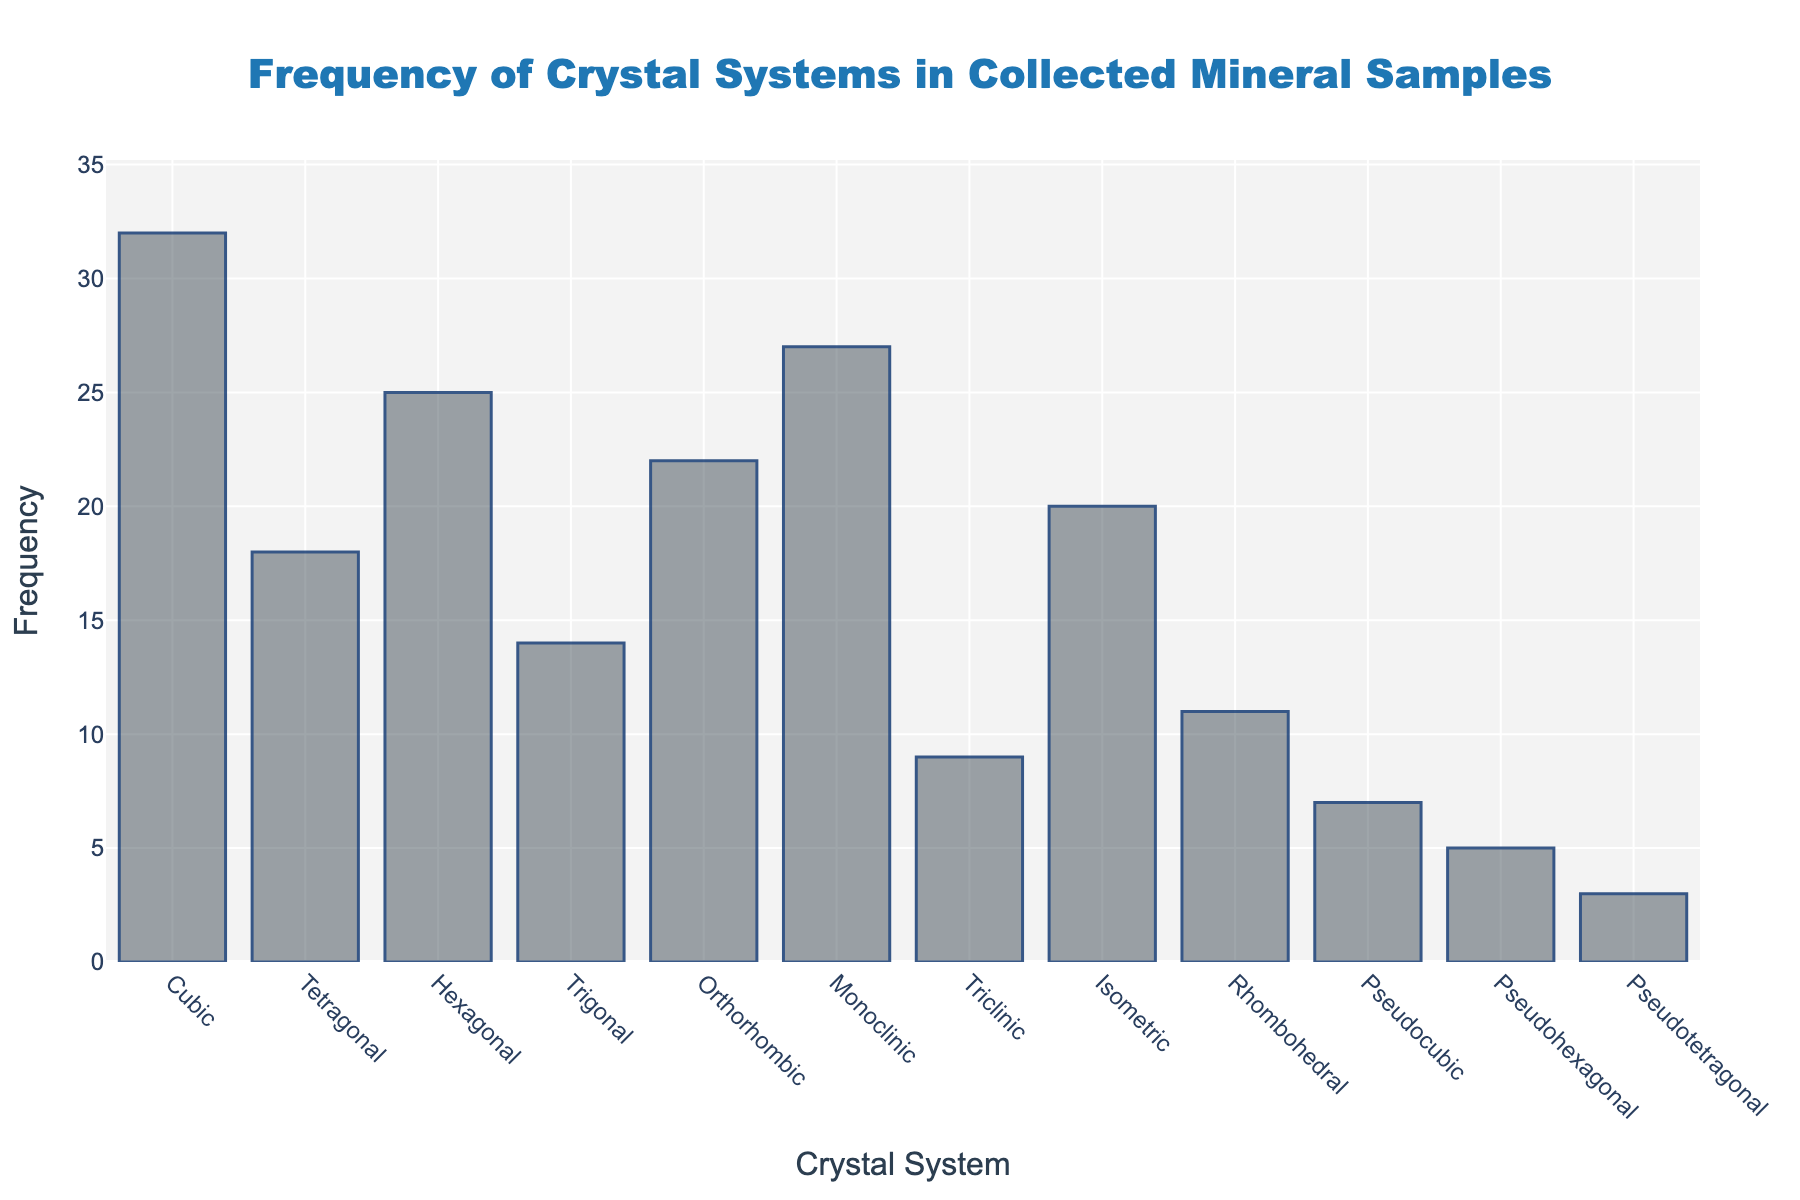What is the most frequently found crystal system in the collected mineral samples? Identify the bar with the highest value on the y-axis, which represents frequency. The highest bar corresponds to the cubic crystal system at a frequency of 32.
Answer: Cubic Which two crystal systems have the lowest frequencies? Identify the bars with the lowest heights on the y-axis. The pseudohexagonal and pseudotetragonal systems have the lowest frequencies at 5 and 3, respectively.
Answer: Pseudohexagonal and Pseudotetragonal What is the total frequency of orthorhombic, monoclinic, and triclinic crystal systems combined? Sum the frequencies of the orthorhombic (22), monoclinic (27), and triclinic (9) systems. Add these together: 22 + 27 + 9 = 58.
Answer: 58 How does the frequency of trigonal compare to rhombohedral? Look at the heights of the bars for trigonal (14) and rhombohedral (11) crystal systems. The trigonal system has a higher frequency than the rhombohedral system.
Answer: Trigonal > Rhombohedral What is the average frequency of all crystal systems shown in the chart? Sum the frequencies of all crystal systems (32, 18, 25, 14, 22, 27, 9, 20, 11, 7, 5, 3) and divide by the number of systems. Total sum: 32 + 18 + 25 + 14 + 22 + 27 + 9 + 20 + 11 + 7 + 5 + 3 = 193. There are 12 crystal systems, so the average is 193 / 12 ≈ 16.08.
Answer: ~16.08 By how much does the frequency of the cubic crystal system exceed the frequency of the monoclinic crystal system? Subtract the frequency of the monoclinic system (27) from that of the cubic system (32): 32 - 27 = 5.
Answer: 5 How does the combined frequency of isometric and tetragonal crystal systems compare to cubic? Sum the frequencies of the isometric (20) and tetragonal (18) systems: 20 + 18 = 38. Compare this to the frequency of the cubic system (32). The combined frequency (38) is greater than the cubic frequency (32).
Answer: Combined > Cubic Which crystal system's frequency is closest to the average frequency of all systems? Calculate the average frequency (16.08). Identify the system with the frequency closest to this value. The hexagonal system has a frequency of 25, which is the closest to 16.08.
Answer: Hexagonal 